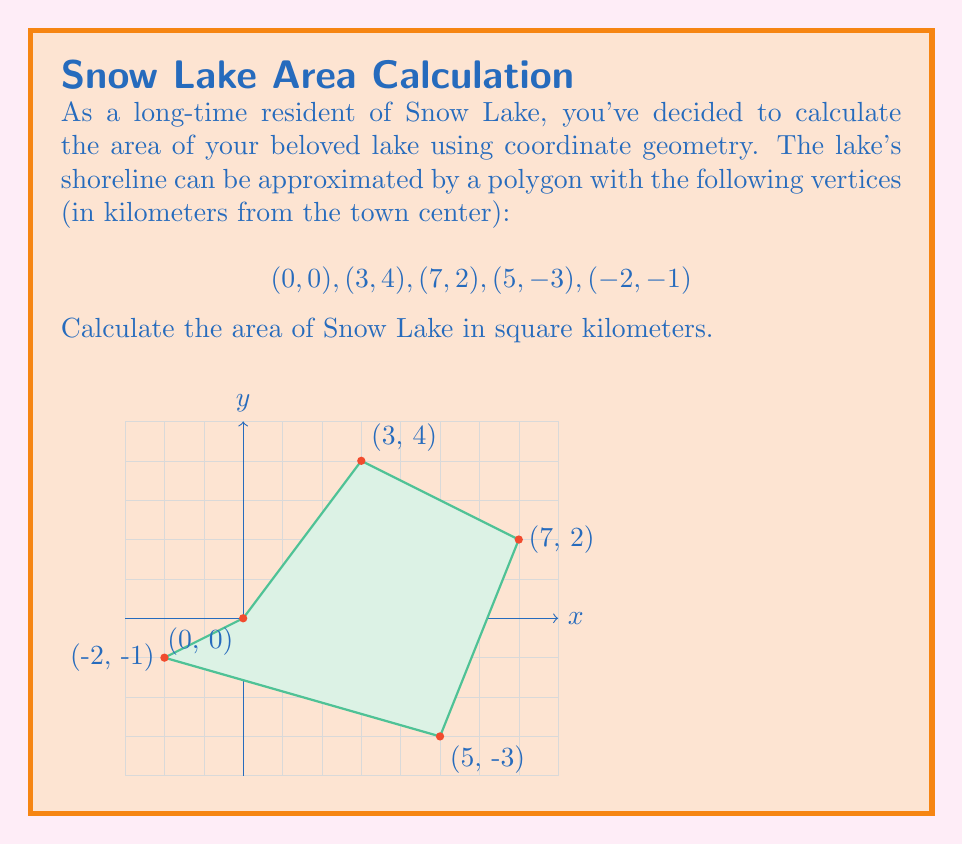What is the answer to this math problem? To calculate the area of the polygon representing Snow Lake, we can use the Shoelace formula (also known as the surveyor's formula). This method is particularly useful for calculating the area of an irregular polygon given its vertices.

The Shoelace formula is:

$$A = \frac{1}{2}|\sum_{i=1}^{n} (x_i y_{i+1} - x_{i+1} y_i)|$$

Where $(x_i, y_i)$ are the coordinates of the $i$-th vertex, and $(x_{n+1}, y_{n+1}) = (x_1, y_1)$.

Let's apply this formula to our vertices:

1) First, let's list out our $x_i y_{i+1}$ and $x_{i+1} y_i$ terms:

   $(0 \cdot 4) - (3 \cdot 0) = 0$
   $(3 \cdot 2) - (7 \cdot 4) = -22$
   $(7 \cdot -3) - (5 \cdot 2) = -31$
   $(5 \cdot -1) - (-2 \cdot -3) = -11$
   $(-2 \cdot 0) - (0 \cdot -1) = 0$

2) Sum these terms:
   $0 + (-22) + (-31) + (-11) + 0 = -64$

3) Take the absolute value:
   $|-64| = 64$

4) Multiply by $\frac{1}{2}$:
   $\frac{1}{2} \cdot 64 = 32$

Therefore, the area of Snow Lake is 32 square kilometers.
Answer: 32 km² 